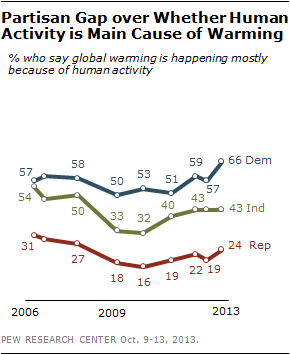Mention a couple of crucial points in this snapshot. The lowest value of the blue line is 50. There has been no increase in the number of Republicans who believe that human activity is the primary cause of global warming since 2006. 